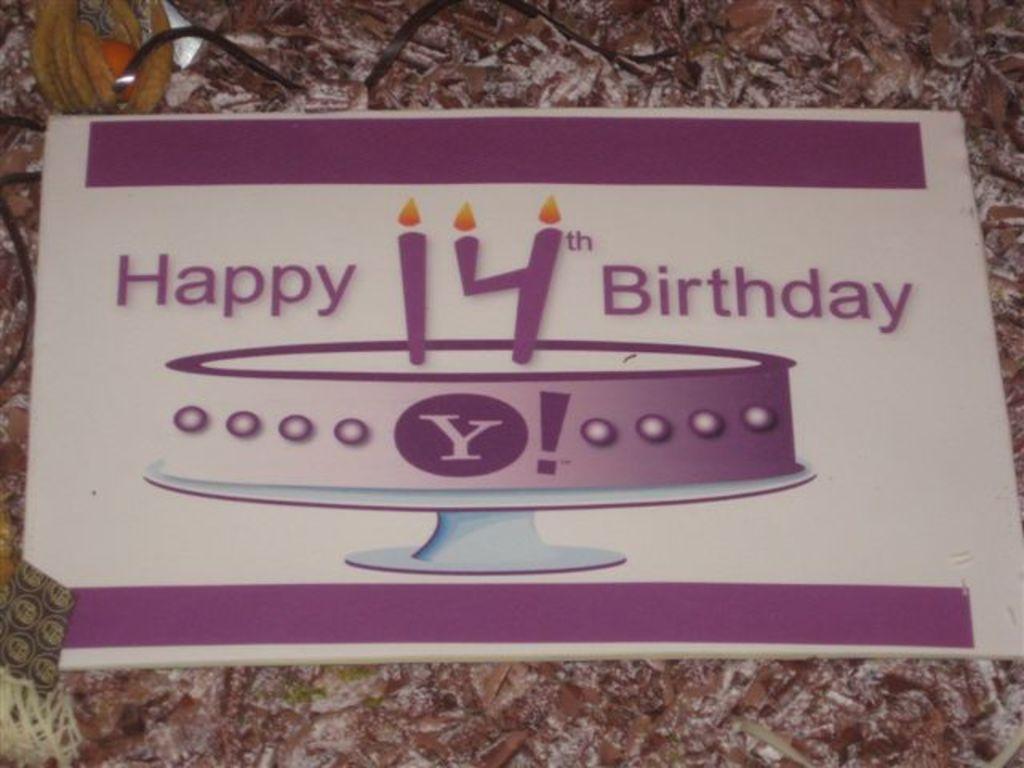In one or two sentences, can you explain what this image depicts? There is a white color thing. On that something is written. Also there is an image of cake on that. 